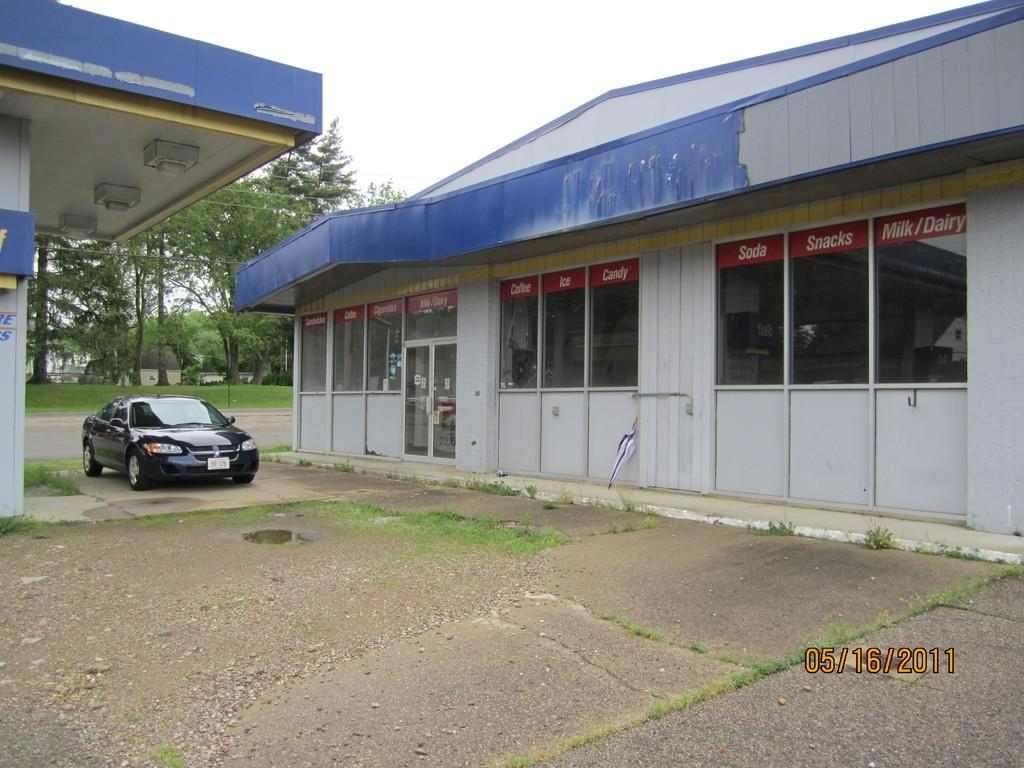What type of structure is visible in the image? There is a building in the image. What object can be seen in the image that is typically used for protection from rain? There is an umbrella in the image. What mode of transportation is present in the image? There is a car in the image. What type of vegetation can be seen in the background of the image? There are trees and grass in the background of the image. What type of surface is visible in the background of the image? There is a road in the background of the image. What part of the natural environment is visible in the background of the image? The sky is visible in the background of the image. Can you tell me how many ducks are arguing under the umbrella in the image? There are no ducks or arguments present in the image; it features a building, an umbrella, a car, trees, grass, a road, and the sky. What type of flock is flying over the building in the image? There are no flocks visible in the image; it only shows a building, an umbrella, a car, trees, grass, a road, and the sky. 